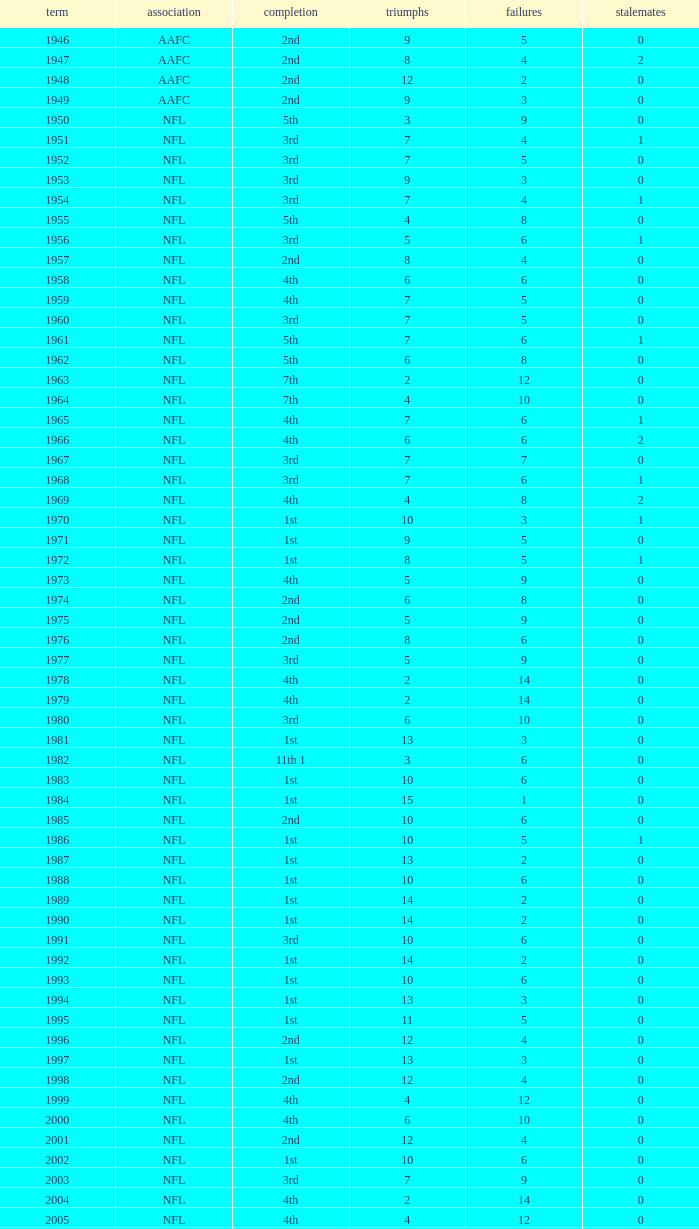What league had a finish of 2nd and 3 losses? AAFC. 